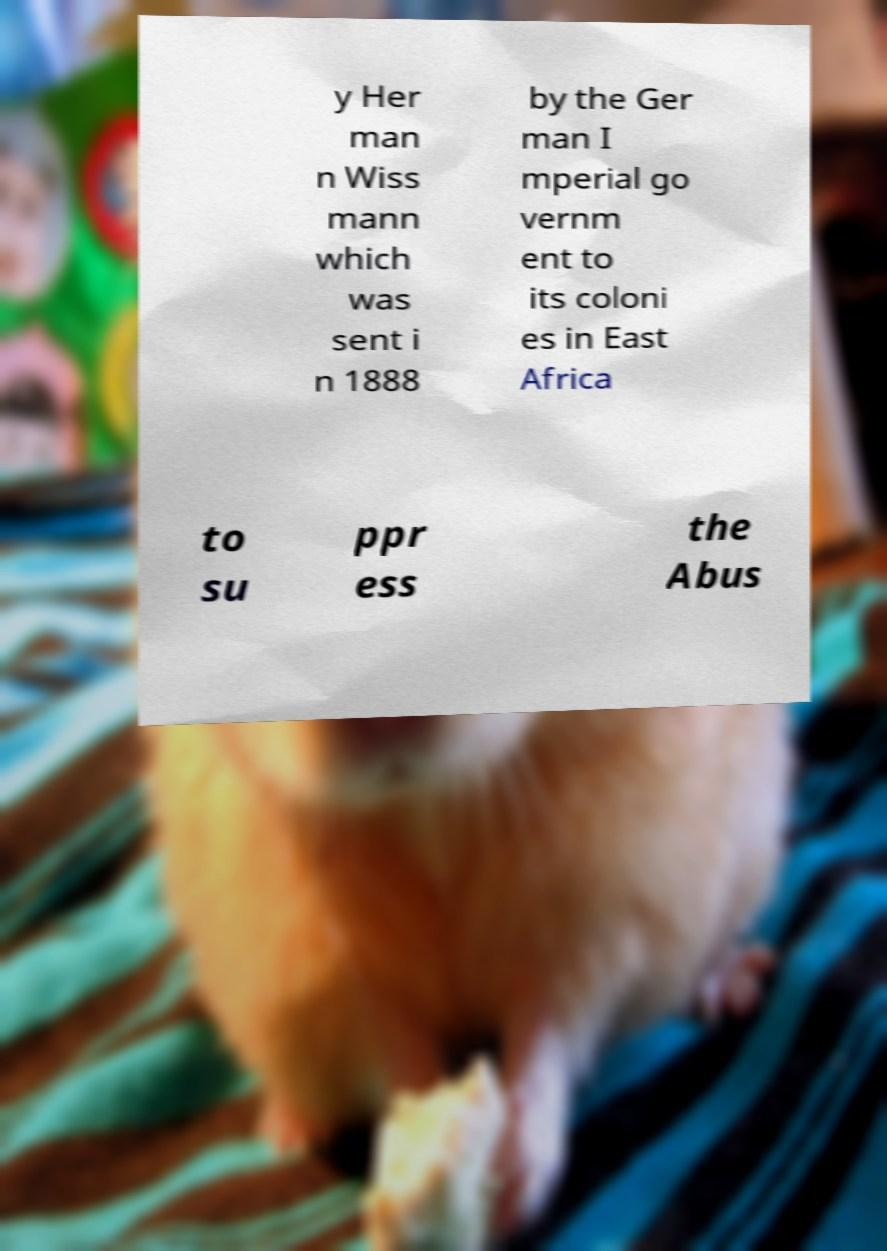Could you assist in decoding the text presented in this image and type it out clearly? y Her man n Wiss mann which was sent i n 1888 by the Ger man I mperial go vernm ent to its coloni es in East Africa to su ppr ess the Abus 